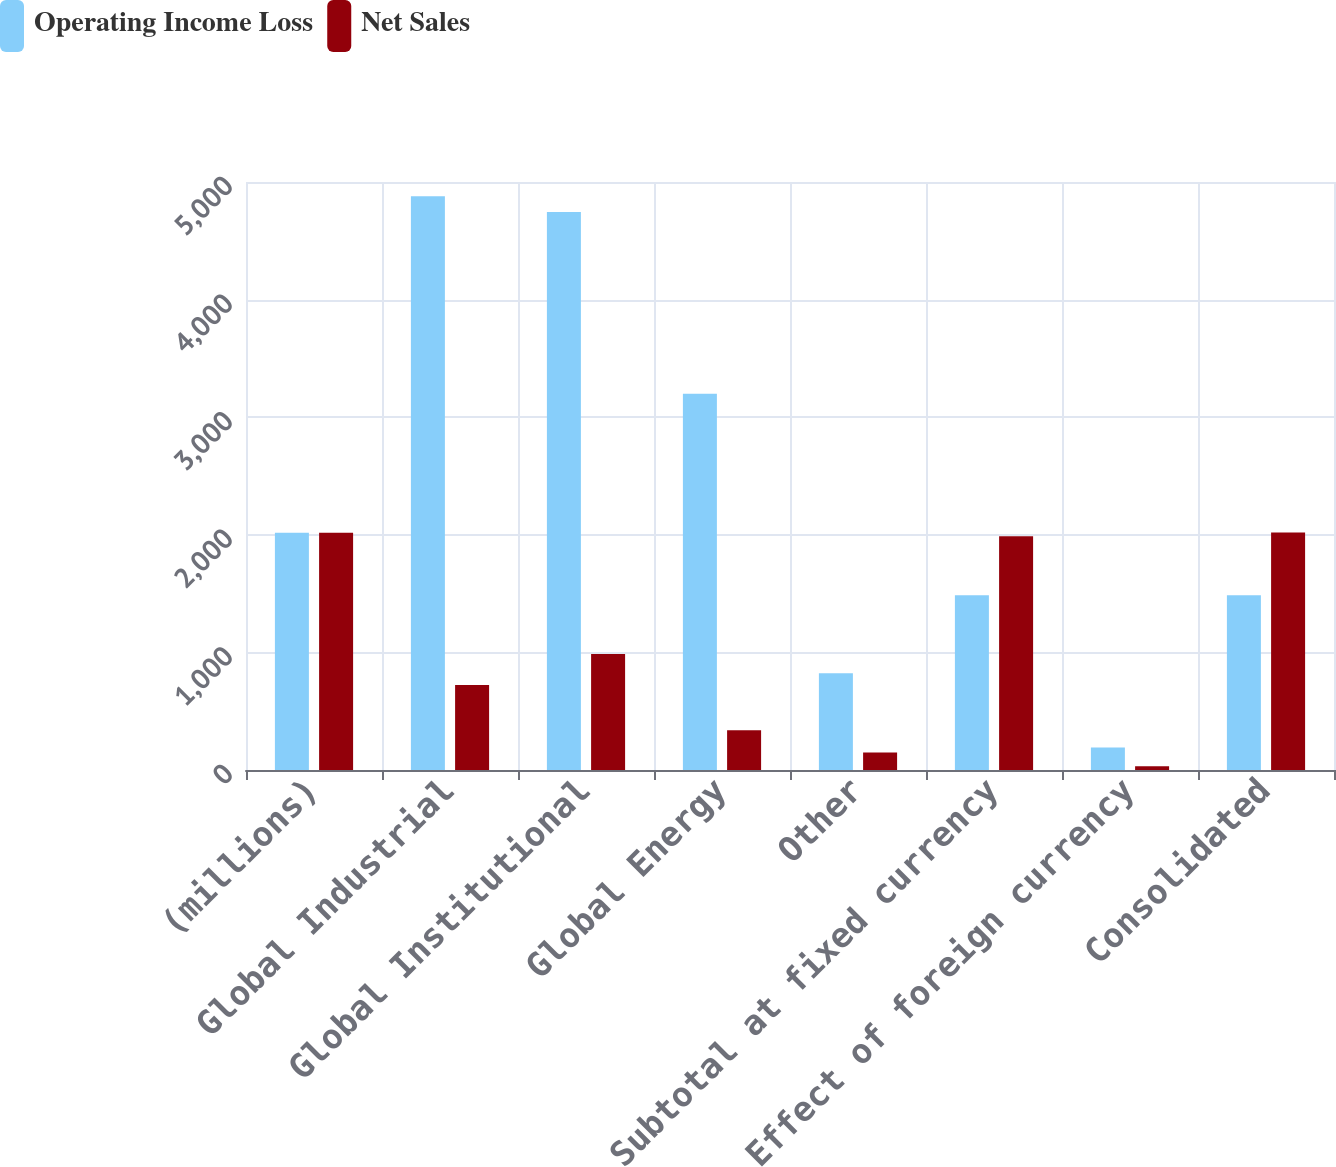Convert chart to OTSL. <chart><loc_0><loc_0><loc_500><loc_500><stacked_bar_chart><ecel><fcel>(millions)<fcel>Global Industrial<fcel>Global Institutional<fcel>Global Energy<fcel>Other<fcel>Subtotal at fixed currency<fcel>Effect of foreign currency<fcel>Consolidated<nl><fcel>Operating Income Loss<fcel>2017<fcel>4878.5<fcel>4744.9<fcel>3199.3<fcel>823.5<fcel>1486.3<fcel>192.1<fcel>1486.3<nl><fcel>Net Sales<fcel>2017<fcel>722<fcel>985.7<fcel>338.5<fcel>149.3<fcel>1986.9<fcel>32.9<fcel>2019.8<nl></chart> 